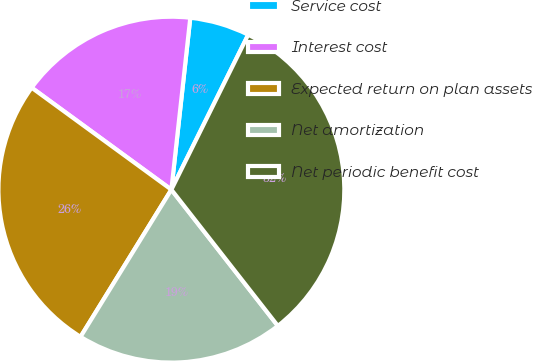Convert chart to OTSL. <chart><loc_0><loc_0><loc_500><loc_500><pie_chart><fcel>Service cost<fcel>Interest cost<fcel>Expected return on plan assets<fcel>Net amortization<fcel>Net periodic benefit cost<nl><fcel>5.58%<fcel>16.71%<fcel>26.23%<fcel>19.36%<fcel>32.11%<nl></chart> 